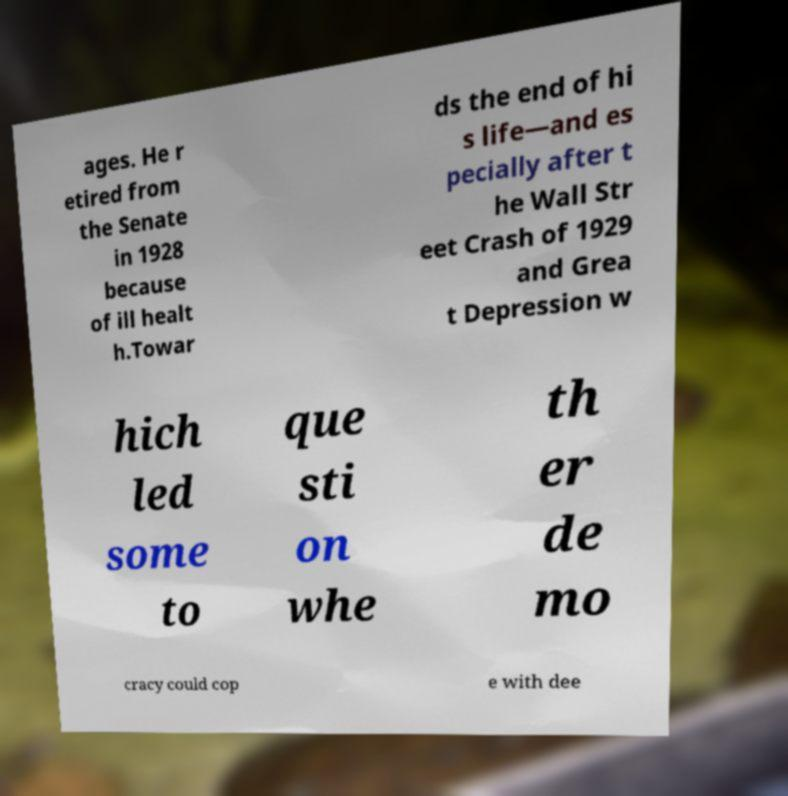There's text embedded in this image that I need extracted. Can you transcribe it verbatim? ages. He r etired from the Senate in 1928 because of ill healt h.Towar ds the end of hi s life—and es pecially after t he Wall Str eet Crash of 1929 and Grea t Depression w hich led some to que sti on whe th er de mo cracy could cop e with dee 